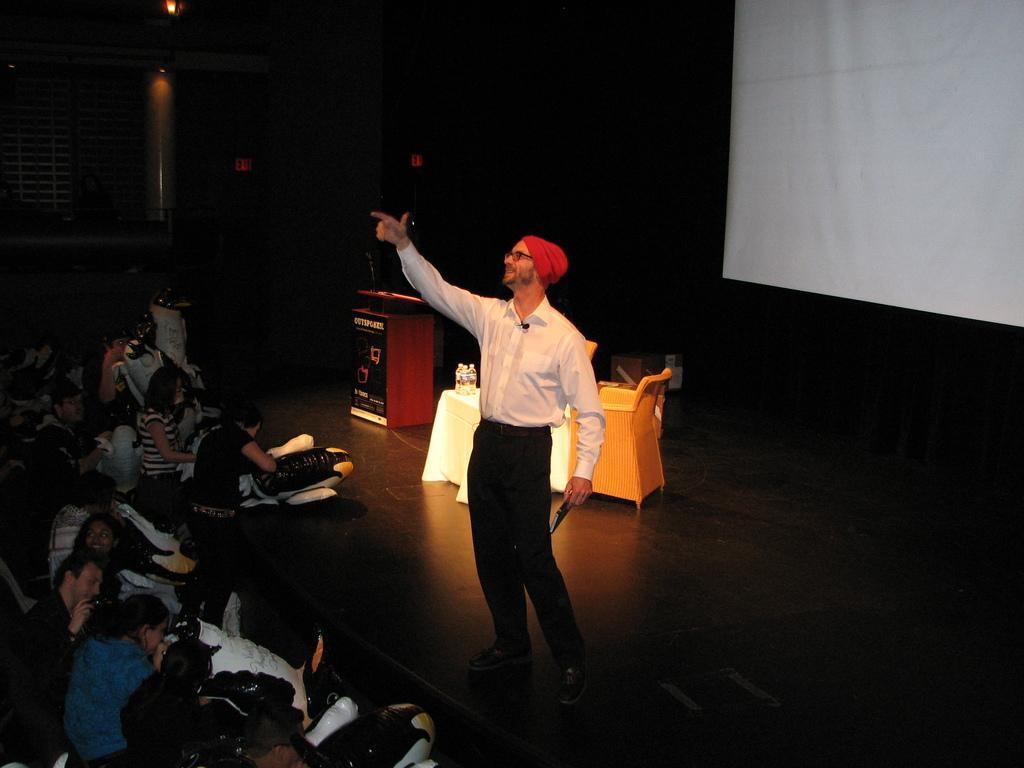Can you describe this image briefly? In this picture we can see a man wearing white shirt, black pant and a red hat standing on the stage we have some people sitting on the chairs and some standing in front of him and behind him there is a desk, two chairs and a table on which there are some bottles in it and a projector screen. 